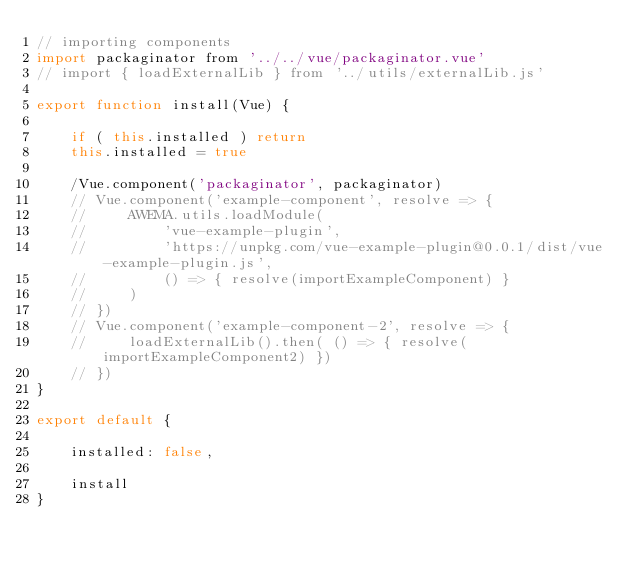Convert code to text. <code><loc_0><loc_0><loc_500><loc_500><_JavaScript_>// importing components
import packaginator from '../../vue/packaginator.vue'
// import { loadExternalLib } from '../utils/externalLib.js'

export function install(Vue) {

    if ( this.installed ) return
    this.installed = true

    /Vue.component('packaginator', packaginator)
    // Vue.component('example-component', resolve => {
    //     AWEMA.utils.loadModule(
    //         'vue-example-plugin',
    //         'https://unpkg.com/vue-example-plugin@0.0.1/dist/vue-example-plugin.js',
    //         () => { resolve(importExampleComponent) }
    //     )
    // })
    // Vue.component('example-component-2', resolve => {
    //     loadExternalLib().then( () => { resolve(importExampleComponent2) })
    // })
}

export default {

    installed: false,

    install
}
</code> 